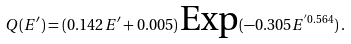<formula> <loc_0><loc_0><loc_500><loc_500>Q ( E ^ { \prime } ) = ( 0 . 1 4 2 E ^ { \prime } + 0 . 0 0 5 ) \, \text {Exp} ( - 0 . 3 0 5 E ^ { ^ { \prime } 0 . 5 6 4 } ) \, .</formula> 